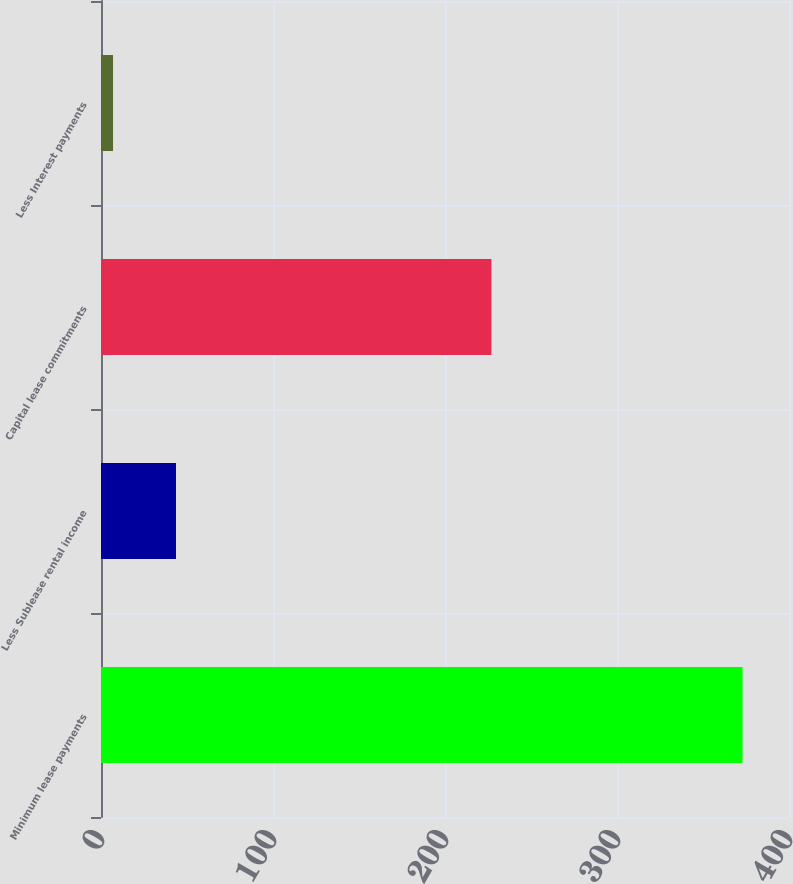<chart> <loc_0><loc_0><loc_500><loc_500><bar_chart><fcel>Minimum lease payments<fcel>Less Sublease rental income<fcel>Capital lease commitments<fcel>Less Interest payments<nl><fcel>373<fcel>43.6<fcel>227<fcel>7<nl></chart> 